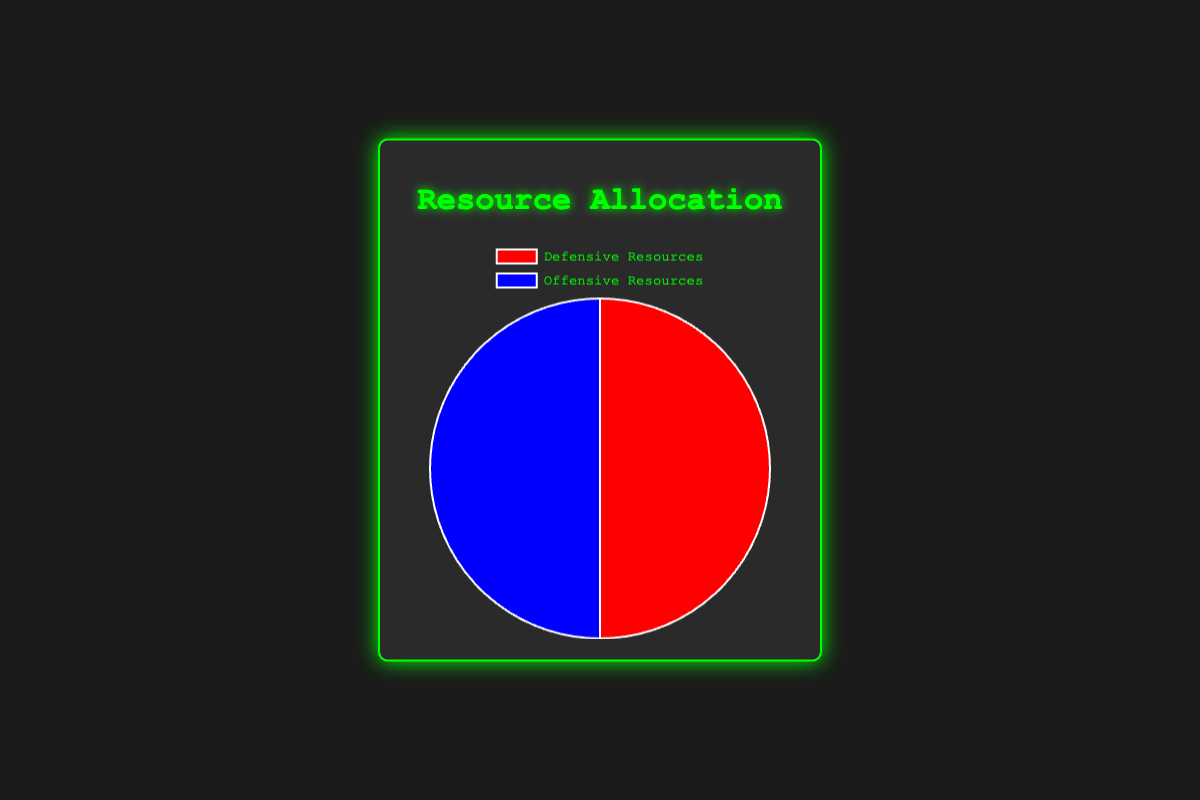What's the total percentage allocated to Defensive Resources and Offensive Resources individually? Each category (Defensive and Offensive) totals 100%. The pie chart displays that Defensive Resources are one half and Offensive Resources are the other half. The individual percentage for each is 100%.
Answer: 100% Which type of resource has an equal allocation between Defensive and Offensive? The pie chart shows that both Defensive Resources and Offensive Resources take up exactly half of the pie chart, making their allocations equal.
Answer: Defensive Resources and Offensive Resources Which resource type has a higher allocation: Cybersecurity Measures or Cyber Attacks? To determine this, we simply compare their values from the data. Cybersecurity Measures have 25% and Cyber Attacks have 20%, so Cybersecurity Measures have a higher allocation.
Answer: Cybersecurity Measures What is the combined percentage for Surveillance Systems and Cybersecurity Measures within Defensive Resources? We add the percentages of Surveillance Systems (45%) and Cybersecurity Measures (25%) to get the total. 45% + 25% = 70%.
Answer: 70% How does the allocation for Recruitment and Training compare to that for Operational Planning within Offensive Resources? Both Recruitment and Training and Operational Planning are listed as having 25% allocation each. They have equal allocations within Offensive Resources.
Answer: Equal If the allocation for Cyber Attacks increased by 10%, how would this affect its percentage within Offensive Resources? Currently, Cyber Attacks have 20%. If increased by 10%, it would be 20% + 10% = 30% making the new allocation for Cyber Attacks 30%.
Answer: 30% Which resource within Offensive Resources has the lowest allocation? From the data provided, Cyber Attacks have the lowest allocation within Offensive Resources at 20%.
Answer: Cyber Attacks What would be the average allocation of all resources within Defensive Resources? We calculate the average by summing up all the resource percentages within Defensive Resources and dividing by the number of resources. (45% + 25% + 15% + 15%) / 4 = 100% / 4 = 25%.
Answer: 25% How does the visual color representation distinguish between Defensive and Offensive Resources in the pie chart? From the descriptive code, Defensive Resources are represented in red and Offensive Resources are represented in blue in the pie chart.
Answer: Red and Blue 